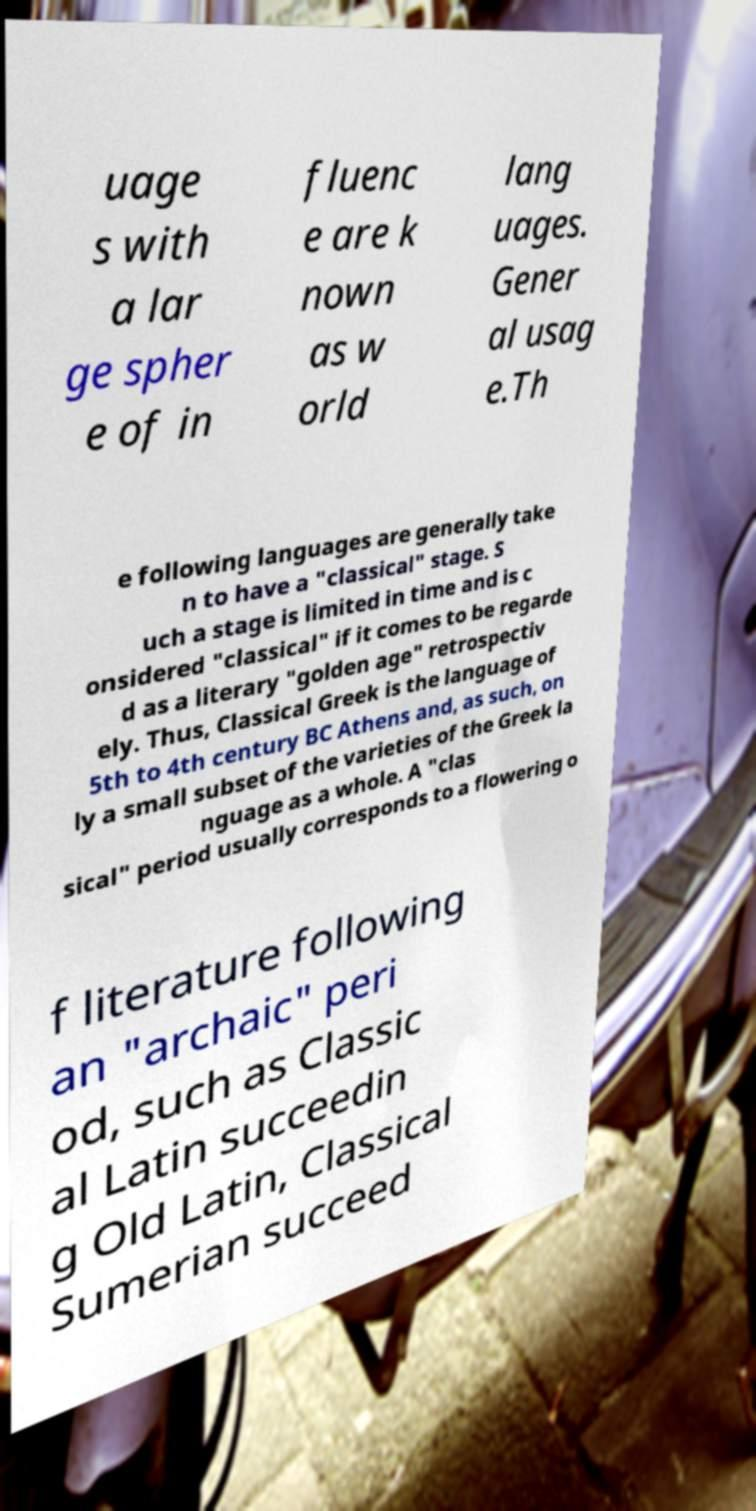Please identify and transcribe the text found in this image. uage s with a lar ge spher e of in fluenc e are k nown as w orld lang uages. Gener al usag e.Th e following languages are generally take n to have a "classical" stage. S uch a stage is limited in time and is c onsidered "classical" if it comes to be regarde d as a literary "golden age" retrospectiv ely. Thus, Classical Greek is the language of 5th to 4th century BC Athens and, as such, on ly a small subset of the varieties of the Greek la nguage as a whole. A "clas sical" period usually corresponds to a flowering o f literature following an "archaic" peri od, such as Classic al Latin succeedin g Old Latin, Classical Sumerian succeed 